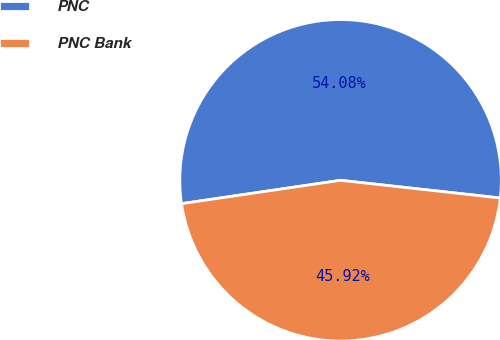<chart> <loc_0><loc_0><loc_500><loc_500><pie_chart><fcel>PNC<fcel>PNC Bank<nl><fcel>54.08%<fcel>45.92%<nl></chart> 